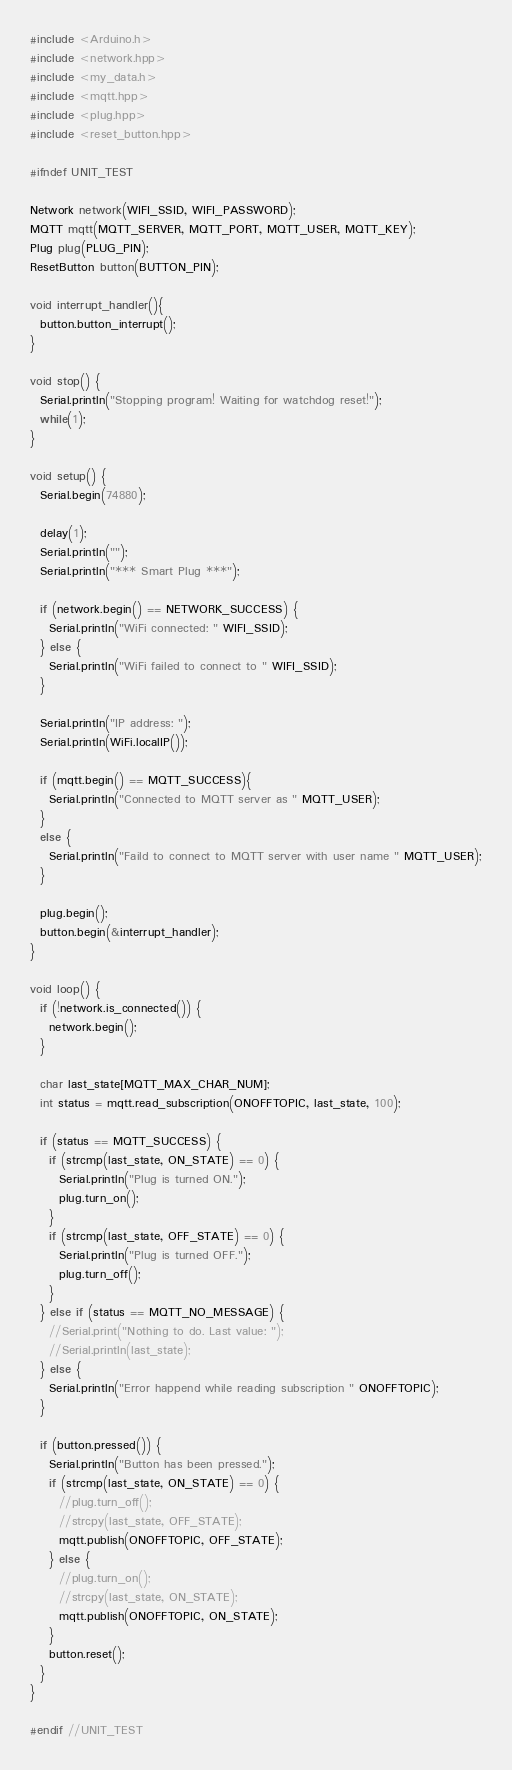Convert code to text. <code><loc_0><loc_0><loc_500><loc_500><_C++_>#include <Arduino.h>
#include <network.hpp>
#include <my_data.h>
#include <mqtt.hpp>
#include <plug.hpp>
#include <reset_button.hpp>

#ifndef UNIT_TEST

Network network(WIFI_SSID, WIFI_PASSWORD);
MQTT mqtt(MQTT_SERVER, MQTT_PORT, MQTT_USER, MQTT_KEY);
Plug plug(PLUG_PIN);
ResetButton button(BUTTON_PIN);

void interrupt_handler(){
  button.button_interrupt();
}

void stop() {
  Serial.println("Stopping program! Waiting for watchdog reset!");
  while(1);
}

void setup() {
  Serial.begin(74880);

  delay(1);
  Serial.println("");
  Serial.println("*** Smart Plug ***");

  if (network.begin() == NETWORK_SUCCESS) {
    Serial.println("WiFi connected: " WIFI_SSID);
  } else {
    Serial.println("WiFi failed to connect to " WIFI_SSID);
  }

  Serial.println("IP address: ");
  Serial.println(WiFi.localIP());

  if (mqtt.begin() == MQTT_SUCCESS){
    Serial.println("Connected to MQTT server as " MQTT_USER);
  }
  else {
    Serial.println("Faild to connect to MQTT server with user name " MQTT_USER);
  }

  plug.begin();
  button.begin(&interrupt_handler);
}

void loop() {
  if (!network.is_connected()) {
    network.begin();
  }

  char last_state[MQTT_MAX_CHAR_NUM];
  int status = mqtt.read_subscription(ONOFFTOPIC, last_state, 100);

  if (status == MQTT_SUCCESS) {
    if (strcmp(last_state, ON_STATE) == 0) {
      Serial.println("Plug is turned ON.");
      plug.turn_on();
    }
    if (strcmp(last_state, OFF_STATE) == 0) {
      Serial.println("Plug is turned OFF.");
      plug.turn_off();
    }
  } else if (status == MQTT_NO_MESSAGE) {
    //Serial.print("Nothing to do. Last value: ");
    //Serial.println(last_state);
  } else {
    Serial.println("Error happend while reading subscription " ONOFFTOPIC);
  }

  if (button.pressed()) {
    Serial.println("Button has been pressed.");
    if (strcmp(last_state, ON_STATE) == 0) {
      //plug.turn_off();
      //strcpy(last_state, OFF_STATE);
      mqtt.publish(ONOFFTOPIC, OFF_STATE);
    } else {
      //plug.turn_on();
      //strcpy(last_state, ON_STATE);
      mqtt.publish(ONOFFTOPIC, ON_STATE);
    }
    button.reset();
  }
}

#endif //UNIT_TEST
</code> 